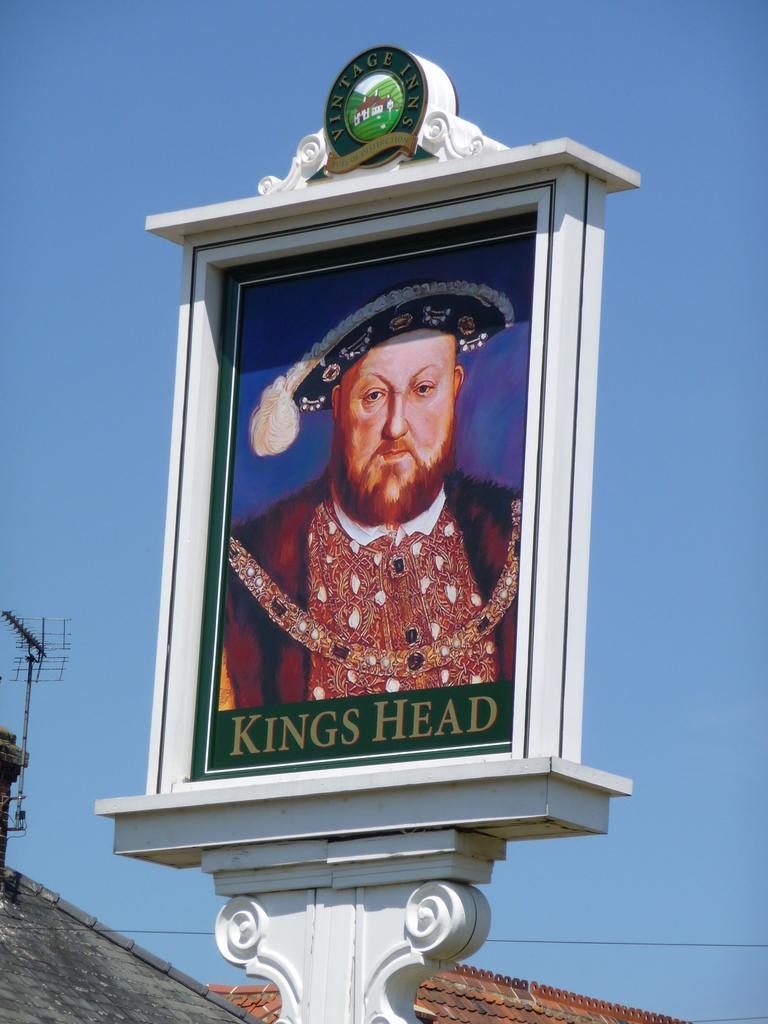Describe this image in one or two sentences. In this image there is a picture frame of a person, behind the picture frame, there is an antenna on a building. 